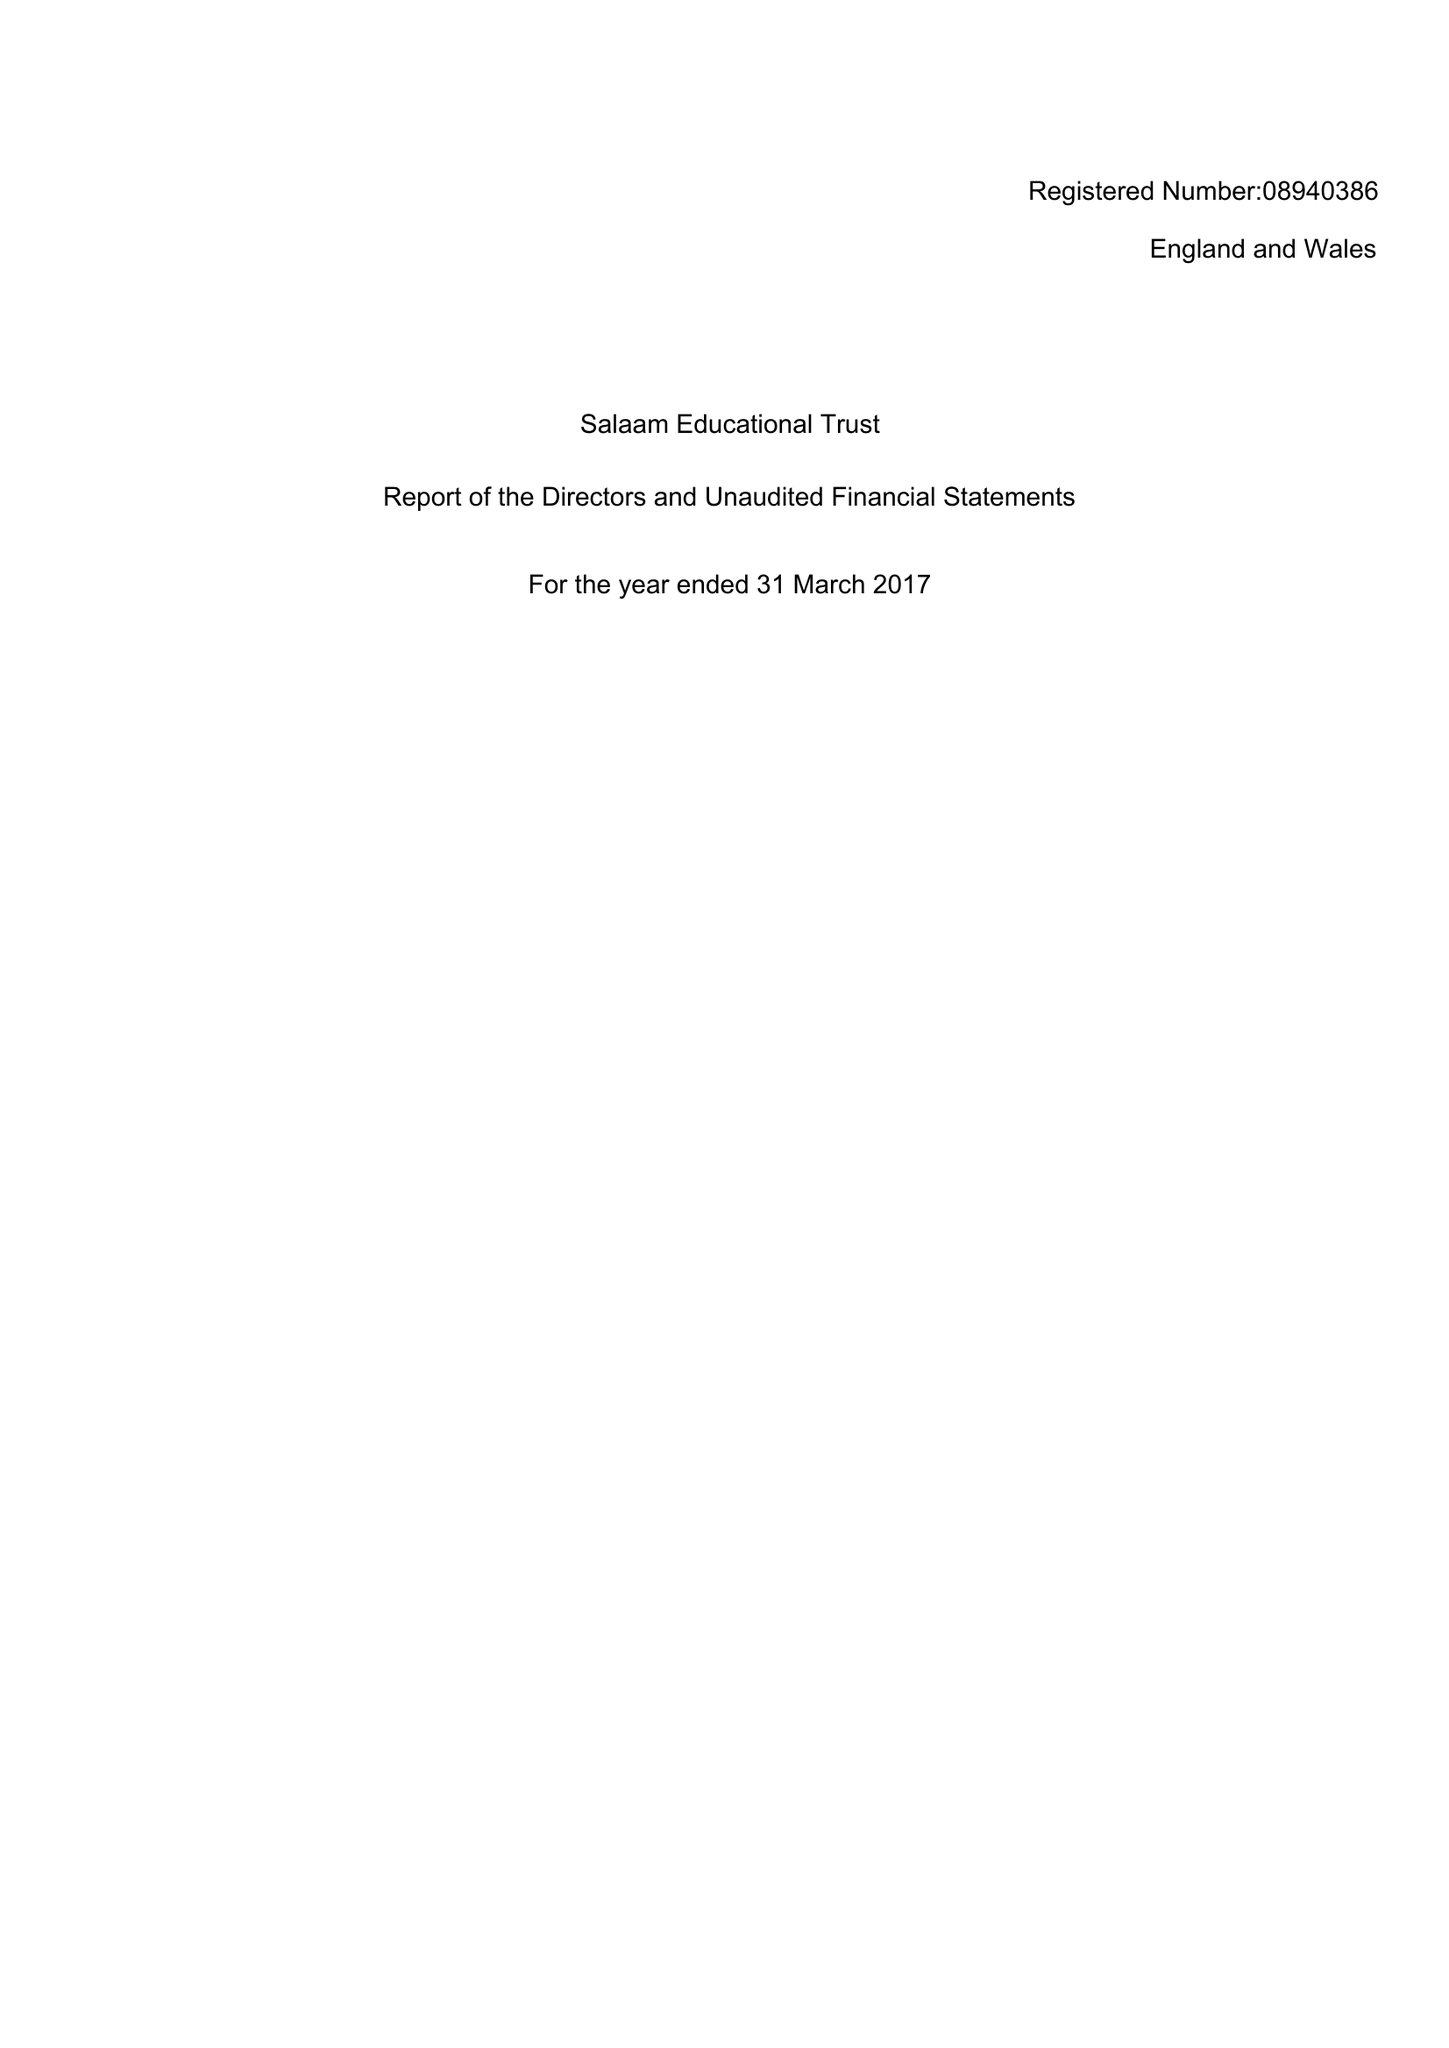What is the value for the address__postcode?
Answer the question using a single word or phrase. PR2 8EA 